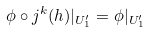<formula> <loc_0><loc_0><loc_500><loc_500>\phi \circ j ^ { k } ( h ) | _ { U _ { 1 } ^ { \prime } } = \phi | _ { U _ { 1 } ^ { \prime } }</formula> 